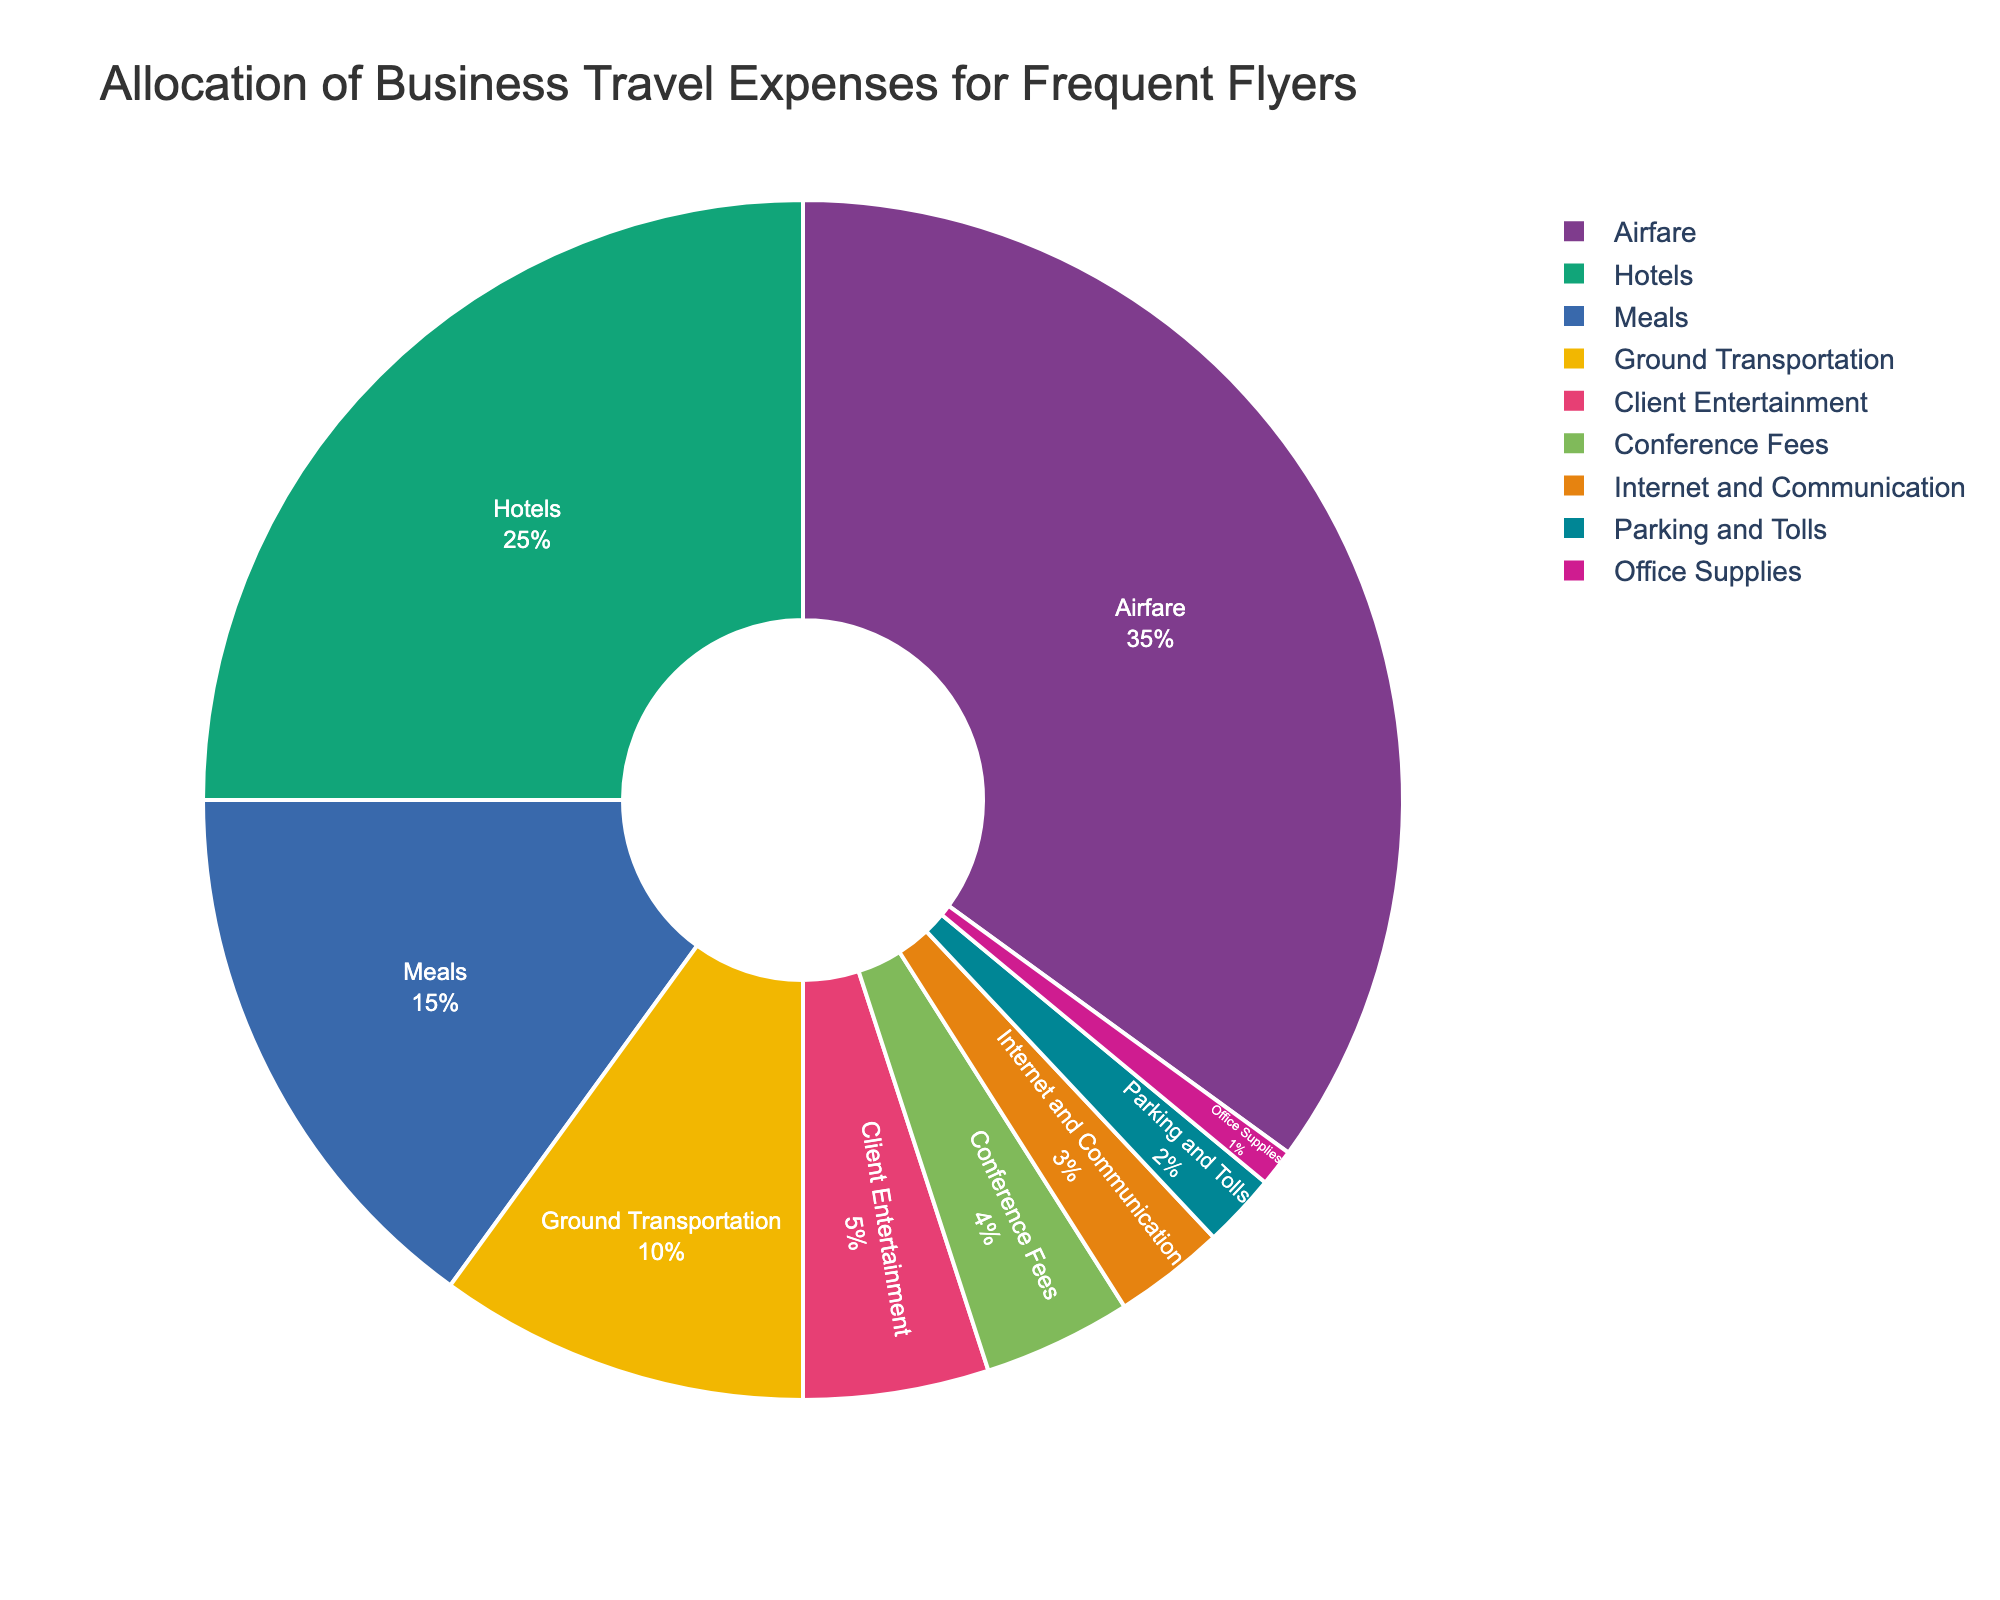what category has the largest allocation of business travel expenses? By looking at the pie chart, it's clear that the category taking up the largest portion of the pie is labeled "Airfare".
Answer: Airfare which categories combined account for more than half of the total expenses? "Airfare" accounts for 35%, and "Hotels" for 25%. Adding these two categories together gives 35% + 25% = 60%, which is more than half of the total expenses.
Answer: Airfare and Hotels what is the total percentage of expenses allocated to Meals, Ground Transportation, and Client Entertainment? Summing the percentages for Meals (15%), Ground Transportation (10%), and Client Entertainment (5%) results in 15% + 10% + 5% = 30%.
Answer: 30% which category has the smallest allocation and what percentage does it represent? The smallest segment on the pie chart is labeled "Office Supplies," which represents 1% of the total expenses.
Answer: Office Supplies, 1% how much more is spent on Airfare compared to Client Entertainment? The percentage for Airfare is 35% and for Client Entertainment is 5%. The difference is 35% - 5% = 30%.
Answer: 30% which categories have a combined allocation equal to the percentage for Hotels? "Meals" (15%) and "Ground Transportation" (10%) together add up to the same percentage as "Hotels" (25%). Adding these categories gives 15% + 10% = 25%.
Answer: Meals and Ground Transportation what is the median value of all category percentages? To find the median, first list the percentages in ascending order: 1, 2, 3, 4, 5, 10, 15, 25, 35. Since there are 9 data points, the median is the fifth value in this ordered list, which is 5%.
Answer: 5% which category is represented by the third-largest segment in the pie chart? By observing the pie chart, the third-largest segment is labeled "Meals" with a percentage of 15%.
Answer: Meals if the allocation for Internet and Communication were to increase by 2%, which other category categories would need to decrease by a combined 2% to balance the total allocation? The categories would need to collectively decrease their allocation by 2% to maintain a total of 100%. Categories like Parking and Tolls (2%) or Office Supplies (1%) and Conference Fees (1%) could be adjusted.
Answer: Parking and Tolls or Office Supplies and Conference Fees how does the percentage allocated to Ground Transportation compare to that of Conference Fees and Parking and Tolls combined? Ground Transportation accounts for 10%, whereas Conference Fees (4%) and Parking and Tolls (2%) combined are 4% + 2% = 6%. Ground Transportation has a higher allocation.
Answer: Higher 